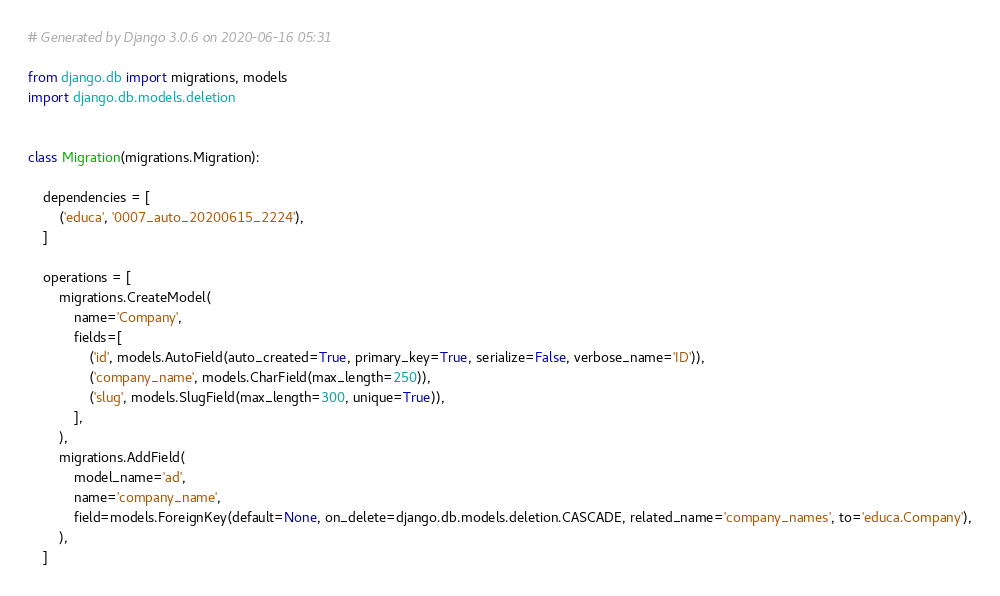Convert code to text. <code><loc_0><loc_0><loc_500><loc_500><_Python_># Generated by Django 3.0.6 on 2020-06-16 05:31

from django.db import migrations, models
import django.db.models.deletion


class Migration(migrations.Migration):

    dependencies = [
        ('educa', '0007_auto_20200615_2224'),
    ]

    operations = [
        migrations.CreateModel(
            name='Company',
            fields=[
                ('id', models.AutoField(auto_created=True, primary_key=True, serialize=False, verbose_name='ID')),
                ('company_name', models.CharField(max_length=250)),
                ('slug', models.SlugField(max_length=300, unique=True)),
            ],
        ),
        migrations.AddField(
            model_name='ad',
            name='company_name',
            field=models.ForeignKey(default=None, on_delete=django.db.models.deletion.CASCADE, related_name='company_names', to='educa.Company'),
        ),
    ]
</code> 